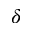Convert formula to latex. <formula><loc_0><loc_0><loc_500><loc_500>\delta</formula> 